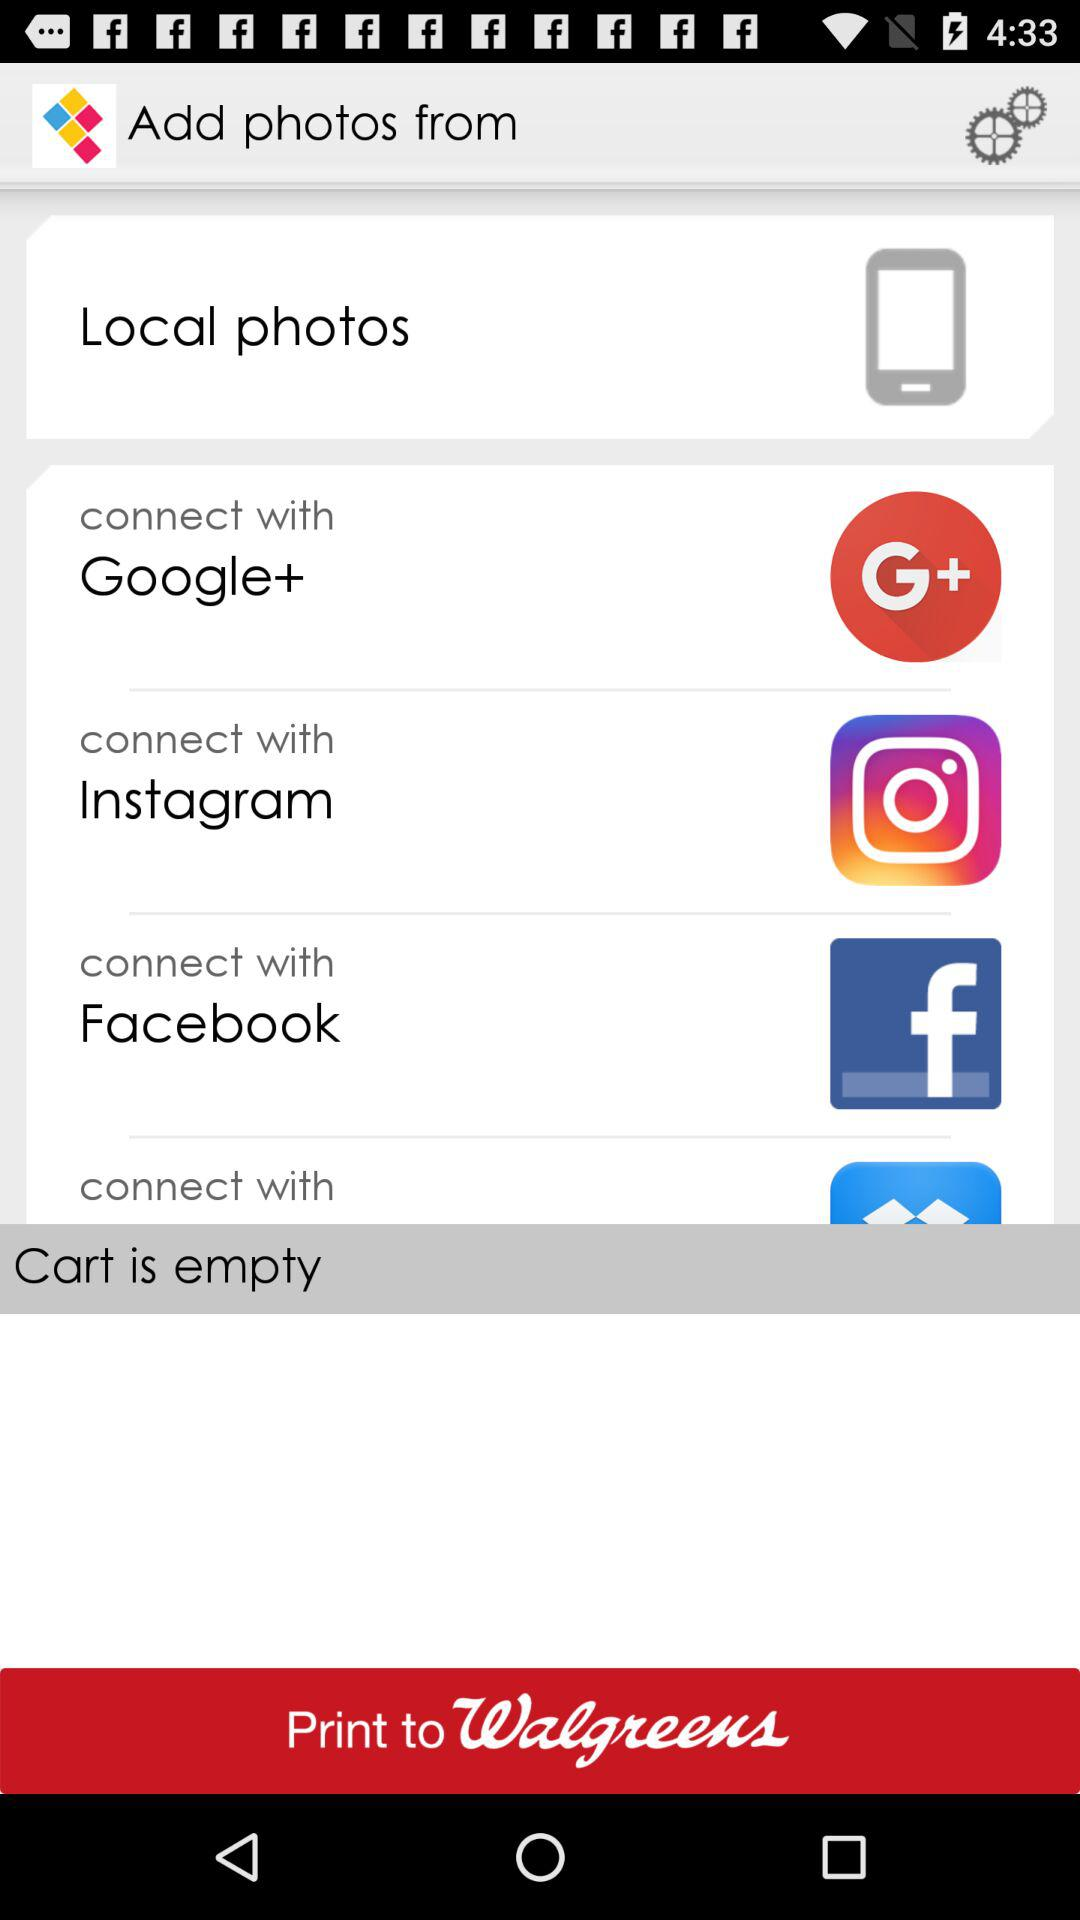What is the number in the cart? The cart is empty. 